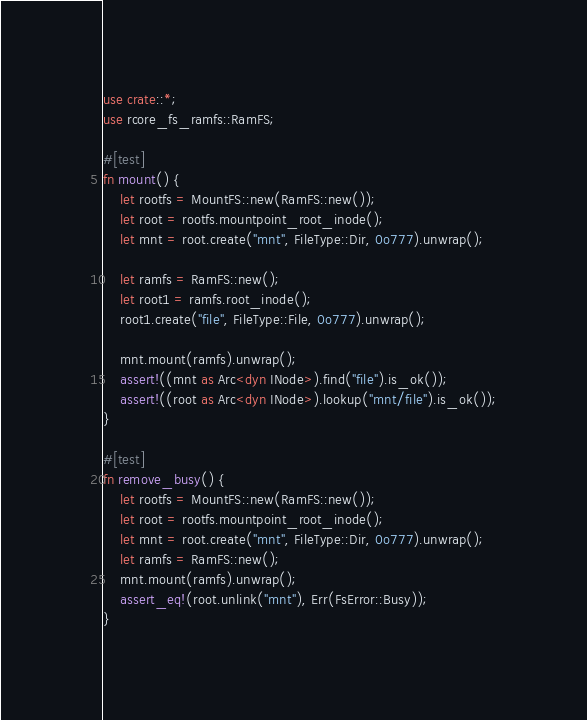Convert code to text. <code><loc_0><loc_0><loc_500><loc_500><_Rust_>use crate::*;
use rcore_fs_ramfs::RamFS;

#[test]
fn mount() {
    let rootfs = MountFS::new(RamFS::new());
    let root = rootfs.mountpoint_root_inode();
    let mnt = root.create("mnt", FileType::Dir, 0o777).unwrap();

    let ramfs = RamFS::new();
    let root1 = ramfs.root_inode();
    root1.create("file", FileType::File, 0o777).unwrap();

    mnt.mount(ramfs).unwrap();
    assert!((mnt as Arc<dyn INode>).find("file").is_ok());
    assert!((root as Arc<dyn INode>).lookup("mnt/file").is_ok());
}

#[test]
fn remove_busy() {
    let rootfs = MountFS::new(RamFS::new());
    let root = rootfs.mountpoint_root_inode();
    let mnt = root.create("mnt", FileType::Dir, 0o777).unwrap();
    let ramfs = RamFS::new();
    mnt.mount(ramfs).unwrap();
    assert_eq!(root.unlink("mnt"), Err(FsError::Busy));
}
</code> 